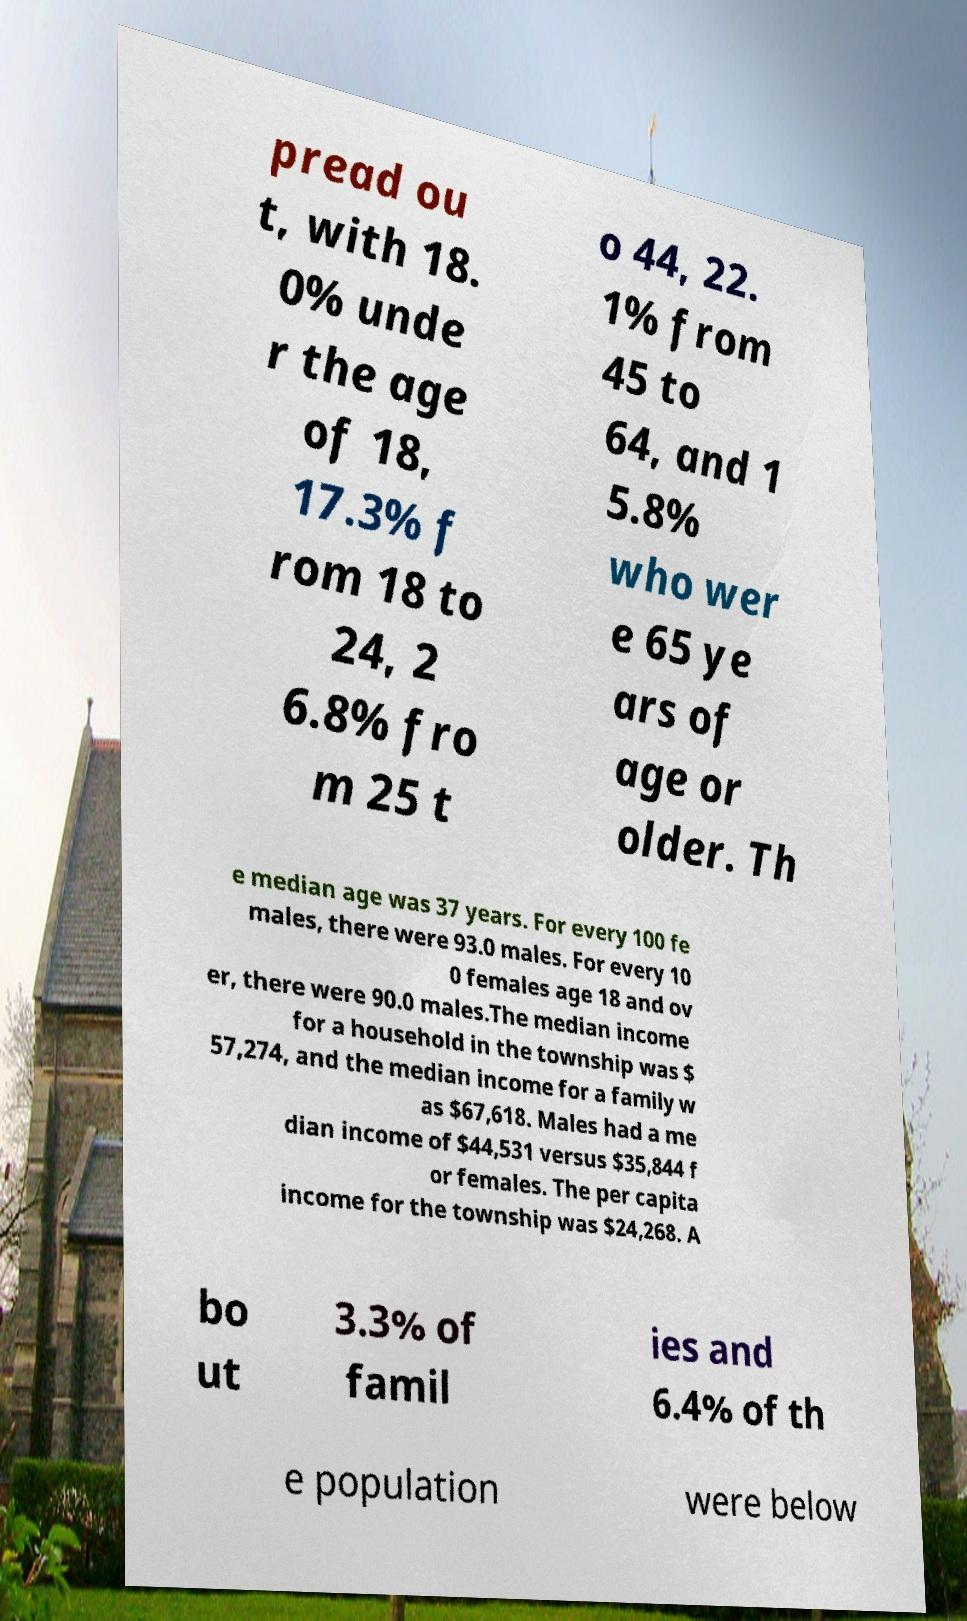I need the written content from this picture converted into text. Can you do that? pread ou t, with 18. 0% unde r the age of 18, 17.3% f rom 18 to 24, 2 6.8% fro m 25 t o 44, 22. 1% from 45 to 64, and 1 5.8% who wer e 65 ye ars of age or older. Th e median age was 37 years. For every 100 fe males, there were 93.0 males. For every 10 0 females age 18 and ov er, there were 90.0 males.The median income for a household in the township was $ 57,274, and the median income for a family w as $67,618. Males had a me dian income of $44,531 versus $35,844 f or females. The per capita income for the township was $24,268. A bo ut 3.3% of famil ies and 6.4% of th e population were below 